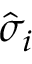<formula> <loc_0><loc_0><loc_500><loc_500>{ \hat { \sigma } } _ { i }</formula> 